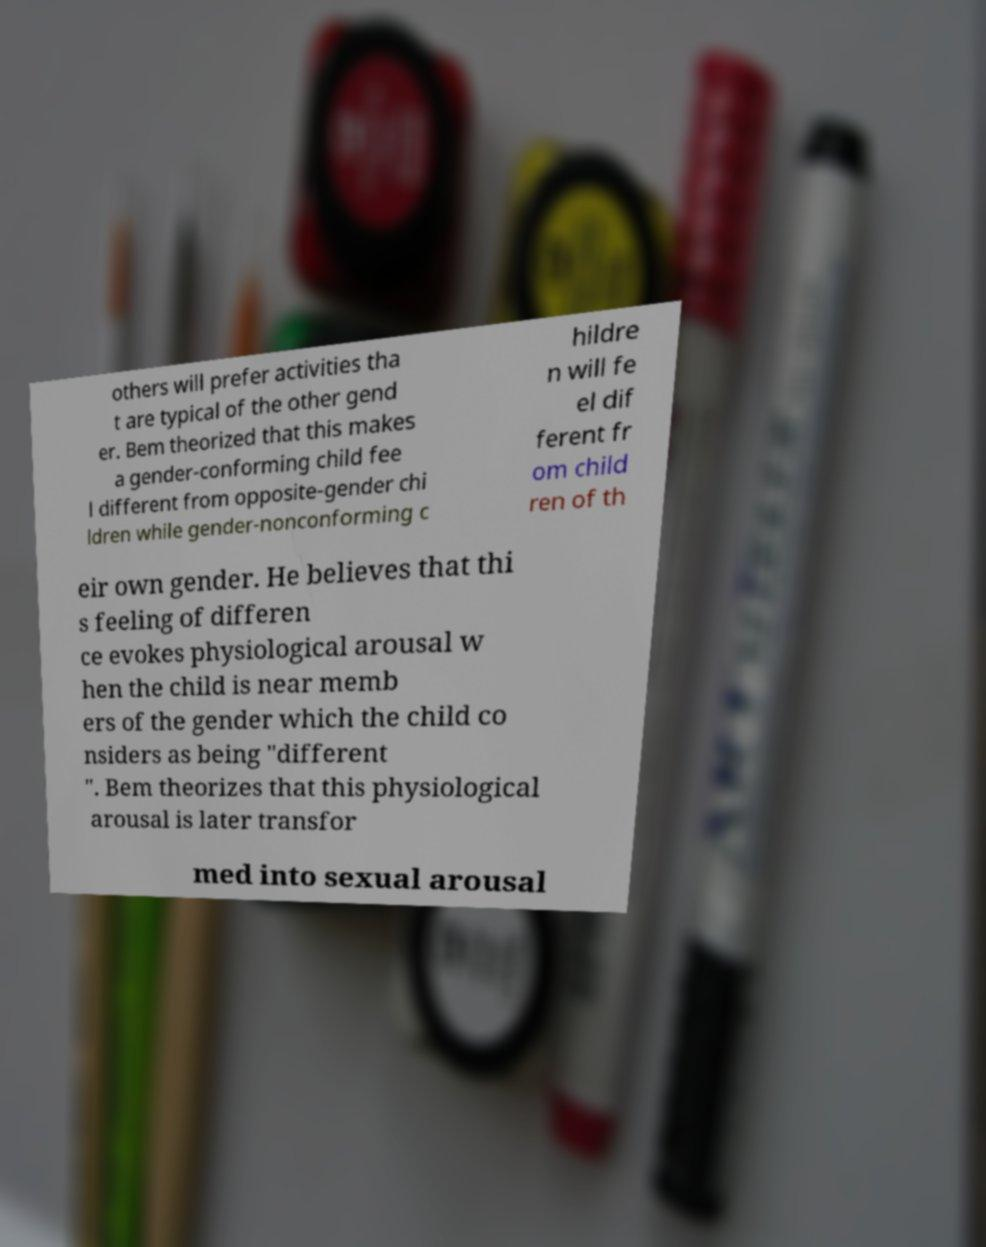Could you assist in decoding the text presented in this image and type it out clearly? others will prefer activities tha t are typical of the other gend er. Bem theorized that this makes a gender-conforming child fee l different from opposite-gender chi ldren while gender-nonconforming c hildre n will fe el dif ferent fr om child ren of th eir own gender. He believes that thi s feeling of differen ce evokes physiological arousal w hen the child is near memb ers of the gender which the child co nsiders as being "different ". Bem theorizes that this physiological arousal is later transfor med into sexual arousal 